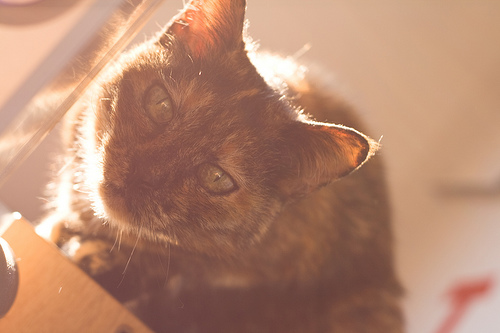<image>
Can you confirm if the cat is next to the green eyes? No. The cat is not positioned next to the green eyes. They are located in different areas of the scene. 